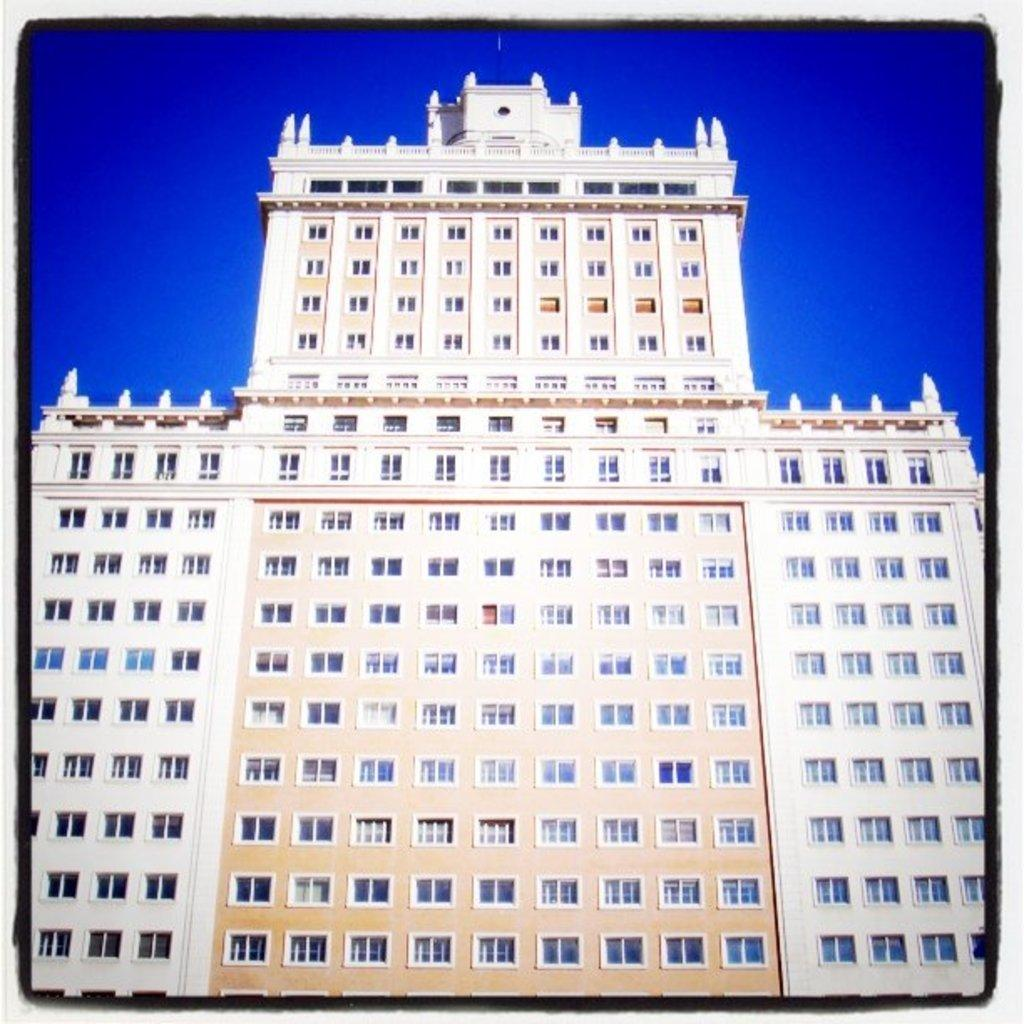What is the main subject of the image? The main subject of the image is a building. Where is the building located in the image? The building is in the center of the image. What color is the building? The building is white in color. What type of shame does the government feel about the building in the image? There is no indication of shame or any government involvement in the image; it simply shows a white building in the center. 